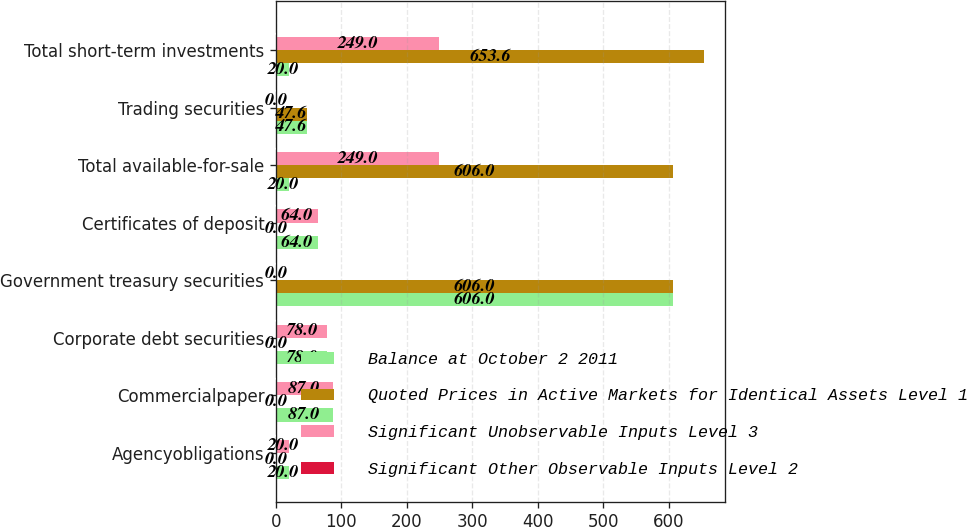Convert chart. <chart><loc_0><loc_0><loc_500><loc_500><stacked_bar_chart><ecel><fcel>Agencyobligations<fcel>Commercialpaper<fcel>Corporate debt securities<fcel>Government treasury securities<fcel>Certificates of deposit<fcel>Total available-for-sale<fcel>Trading securities<fcel>Total short-term investments<nl><fcel>Balance at October 2 2011<fcel>20<fcel>87<fcel>78<fcel>606<fcel>64<fcel>20<fcel>47.6<fcel>20<nl><fcel>Quoted Prices in Active Markets for Identical Assets Level 1<fcel>0<fcel>0<fcel>0<fcel>606<fcel>0<fcel>606<fcel>47.6<fcel>653.6<nl><fcel>Significant Unobservable Inputs Level 3<fcel>20<fcel>87<fcel>78<fcel>0<fcel>64<fcel>249<fcel>0<fcel>249<nl><fcel>Significant Other Observable Inputs Level 2<fcel>0<fcel>0<fcel>0<fcel>0<fcel>0<fcel>0<fcel>0<fcel>0<nl></chart> 